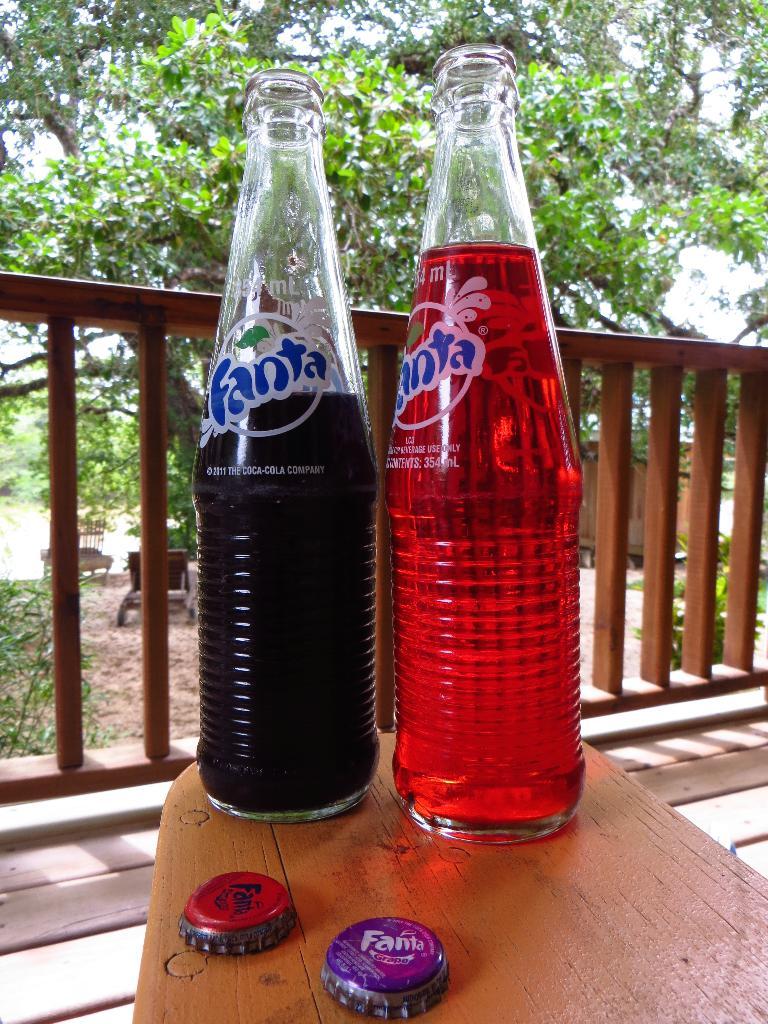What brand of soda is in the bottles?
Provide a short and direct response. Fanta. How many ml is the bottle?
Make the answer very short. 354. 